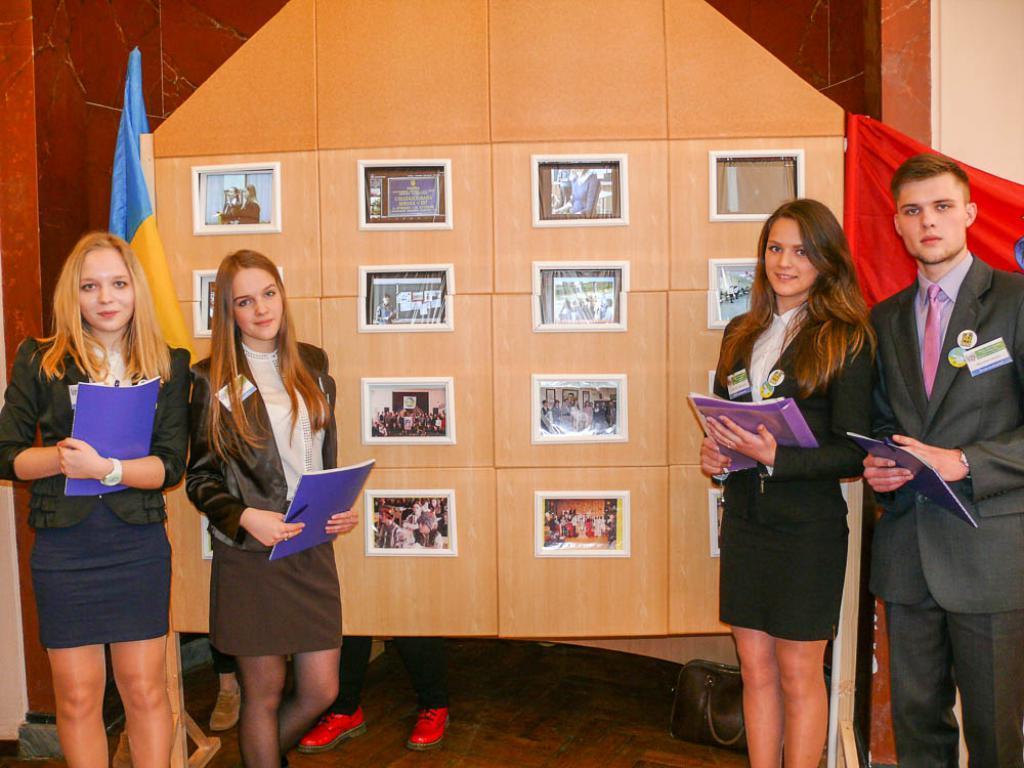Please provide a concise description of this image. In this image we can see a few people, some of them are holding files, there are some photo frames on the wall, there is a flag, and the bag. 